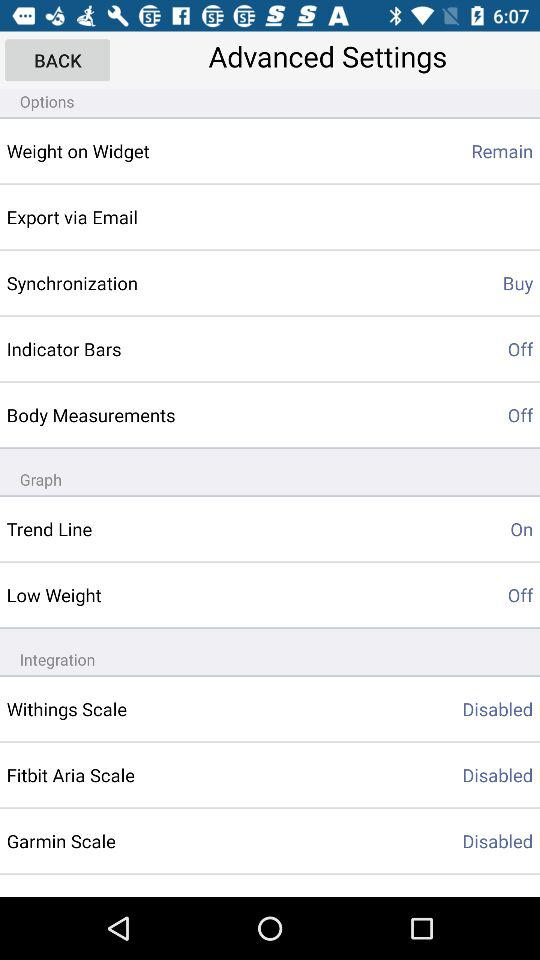What's the setting for body measurements? The setting is "off". 